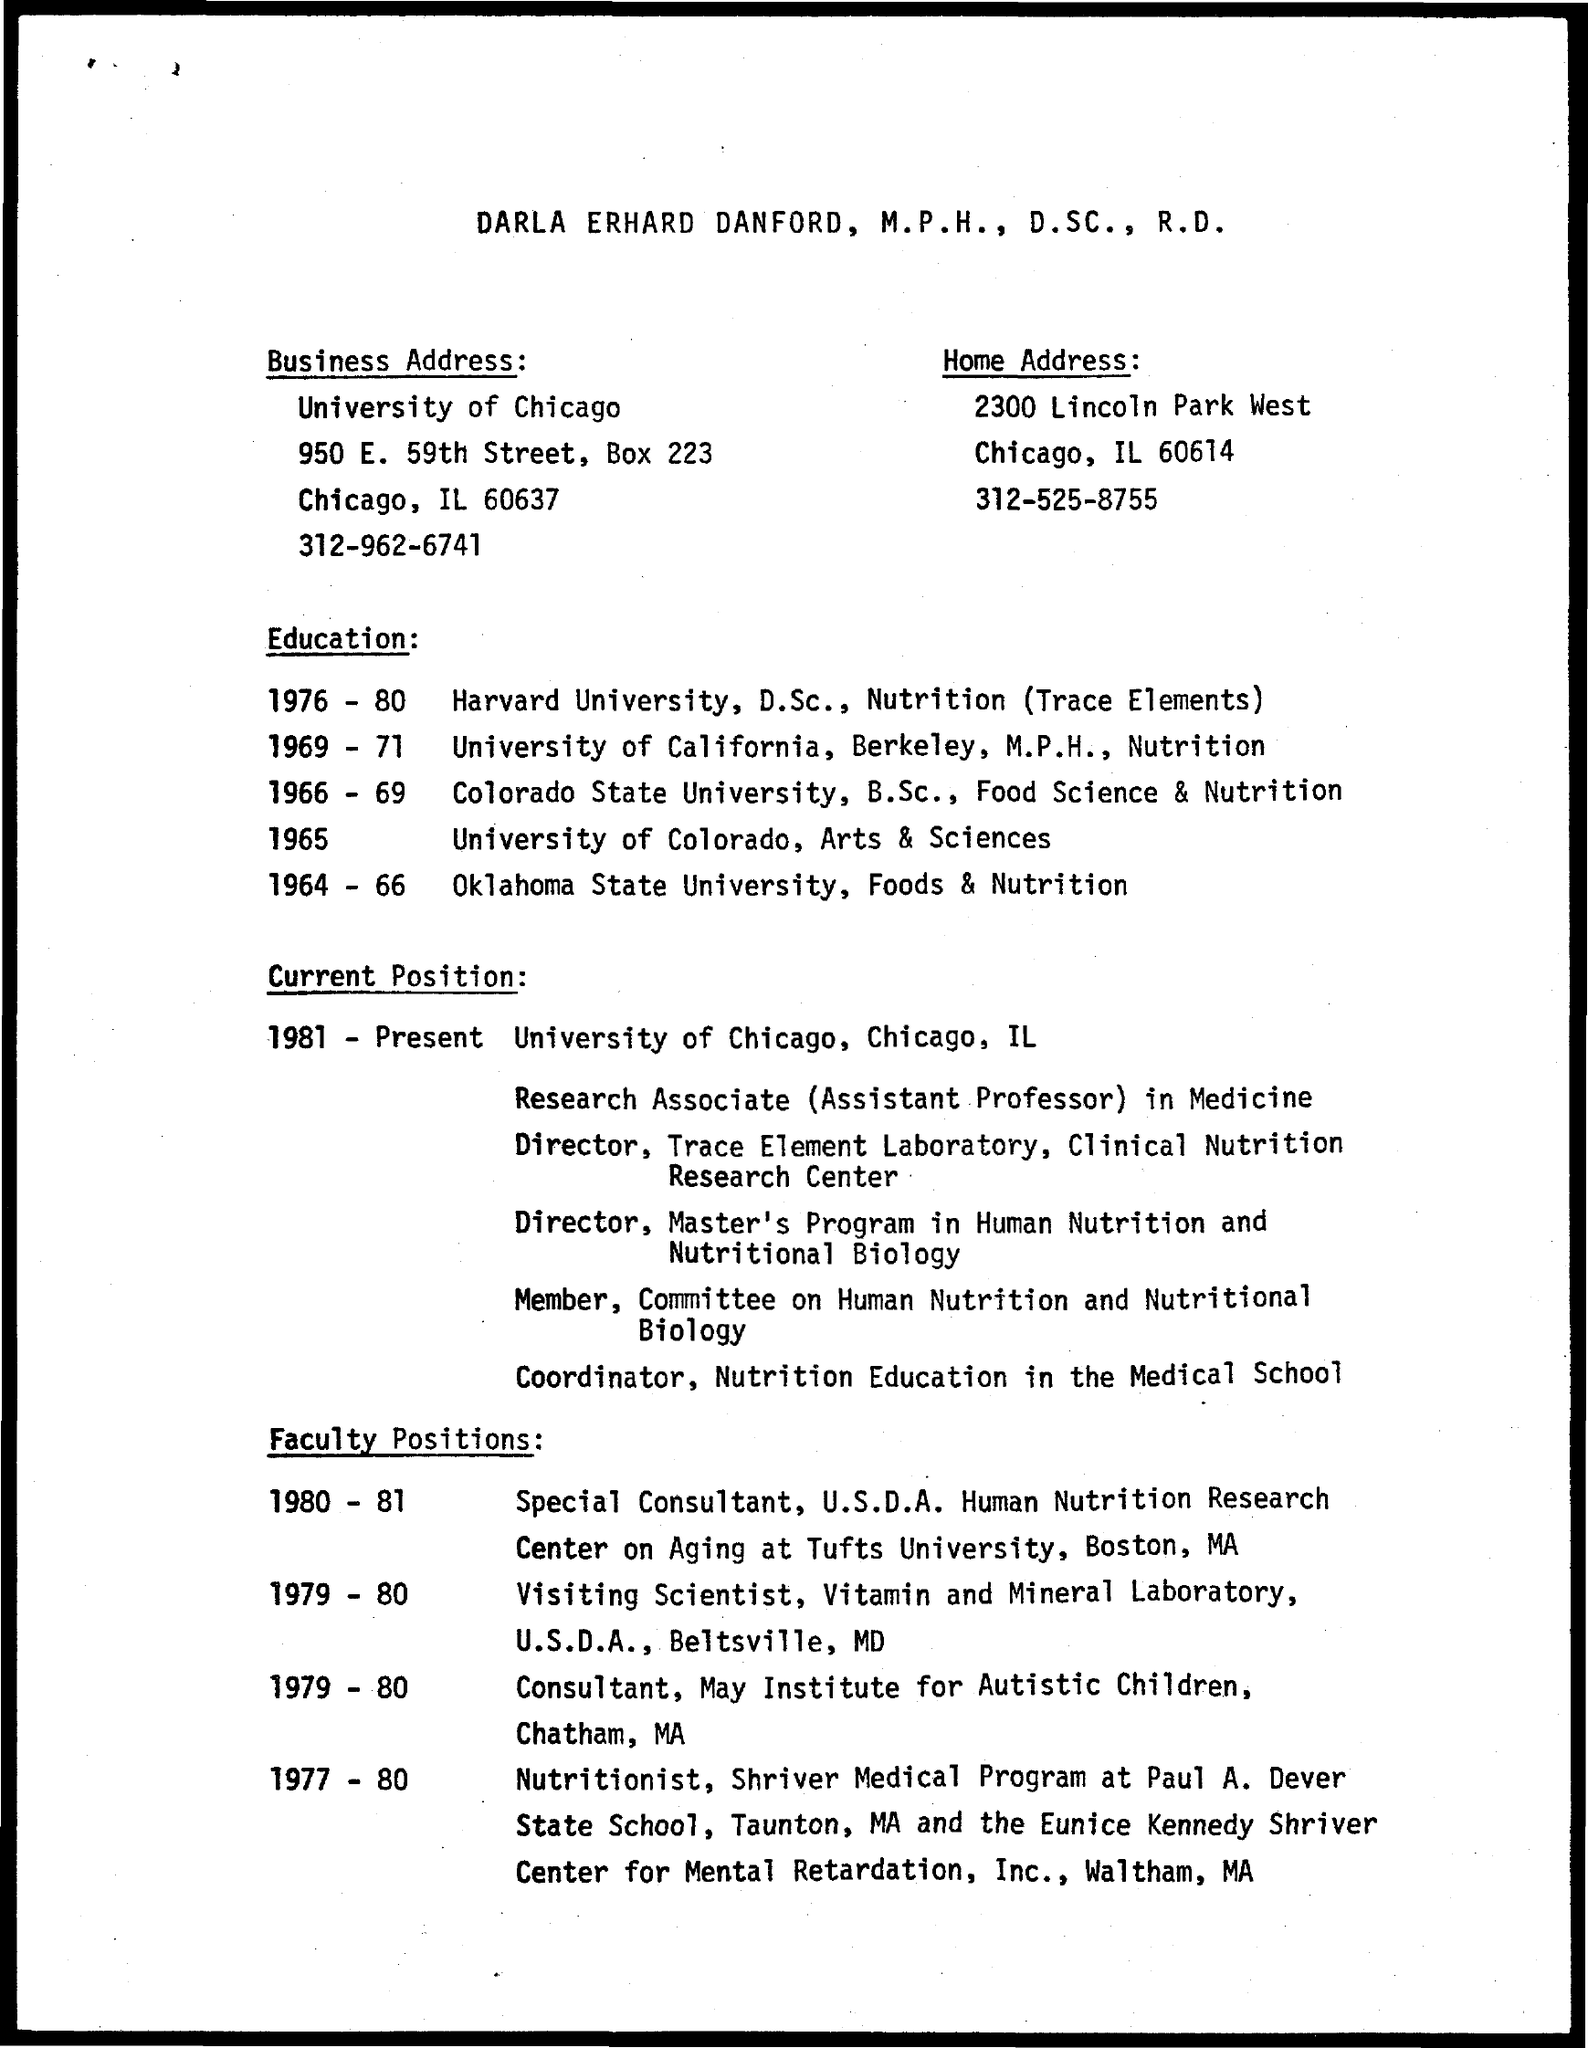Identify some key points in this picture. The business address mentioned a university named "University of Chicago. Darla Erhard Danford received her D.Sc. in nutrition (trace elements) from Harvard University during the years 1976-1980. 